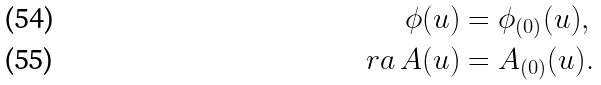Convert formula to latex. <formula><loc_0><loc_0><loc_500><loc_500>\phi ( u ) & = \phi _ { ( 0 ) } ( u ) , \\ \ r a \, A ( u ) & = A _ { ( 0 ) } ( u ) .</formula> 